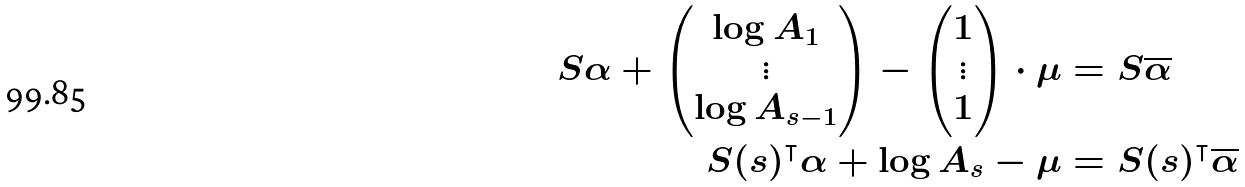Convert formula to latex. <formula><loc_0><loc_0><loc_500><loc_500>S \alpha + \begin{pmatrix} \log A _ { 1 } \\ \vdots \\ \log A _ { s - 1 } \end{pmatrix} - \begin{pmatrix} 1 \\ \vdots \\ 1 \end{pmatrix} \cdot \mu & = S \overline { \alpha } \\ S ( s ) ^ { \intercal } \alpha + \log A _ { s } - \mu & = S ( s ) ^ { \intercal } \overline { \alpha }</formula> 